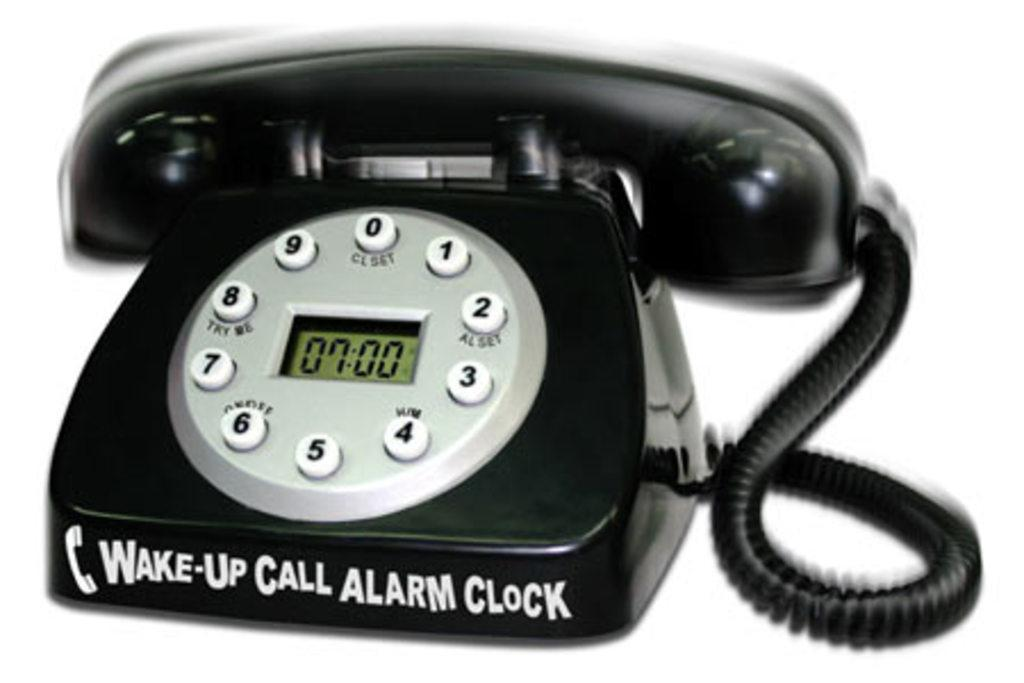<image>
Share a concise interpretation of the image provided. A black telephone is also an alarm clock that can give you wake-up calls. 